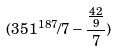Convert formula to latex. <formula><loc_0><loc_0><loc_500><loc_500>( 3 5 1 ^ { 1 8 7 } / 7 - \frac { \frac { 4 2 } { 9 } } { 7 } )</formula> 